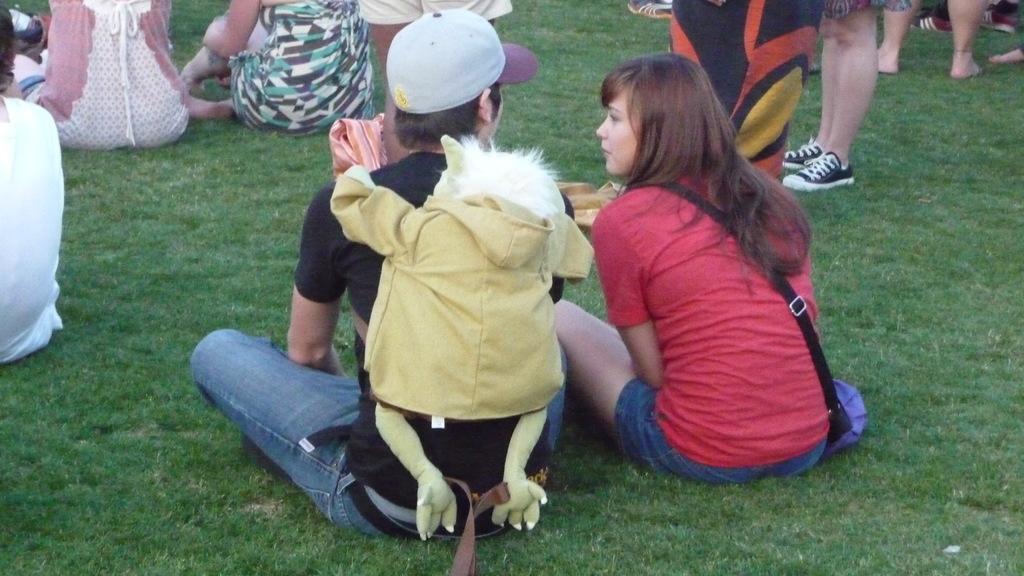Please provide a concise description of this image. In this image in the foreground there is one man and one woman who are sitting and a man is wearing a bag, in the background there are some people who are sitting and some of them are standing. At the bottom there is a fence. 